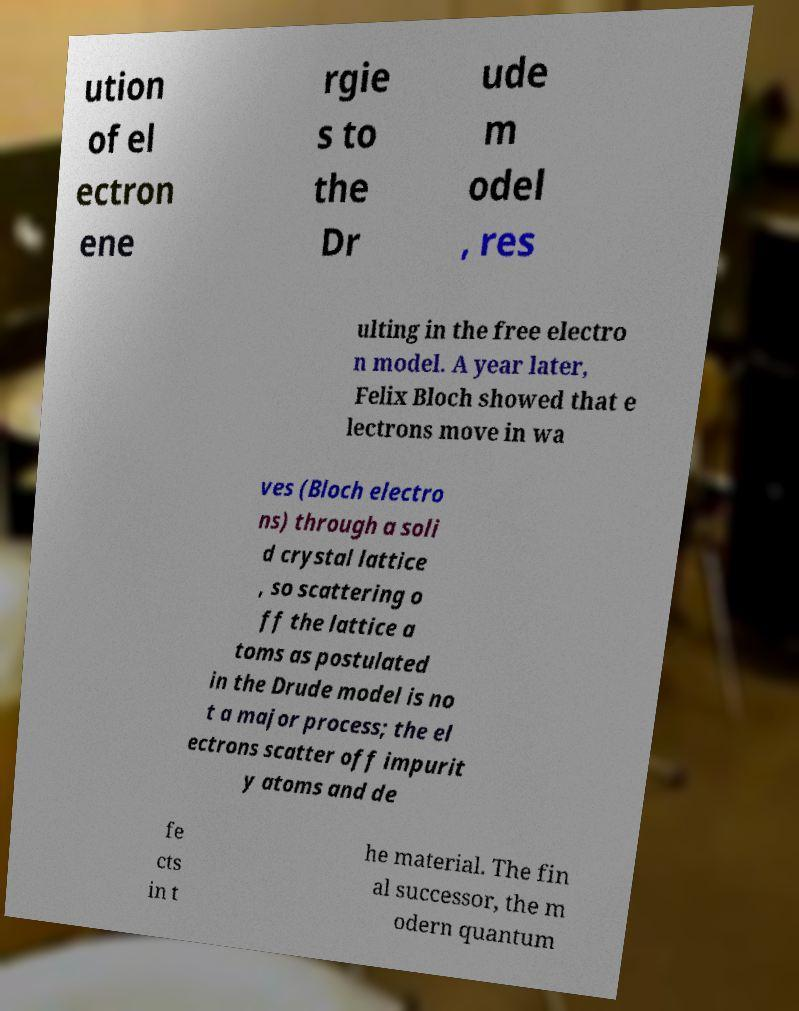There's text embedded in this image that I need extracted. Can you transcribe it verbatim? ution of el ectron ene rgie s to the Dr ude m odel , res ulting in the free electro n model. A year later, Felix Bloch showed that e lectrons move in wa ves (Bloch electro ns) through a soli d crystal lattice , so scattering o ff the lattice a toms as postulated in the Drude model is no t a major process; the el ectrons scatter off impurit y atoms and de fe cts in t he material. The fin al successor, the m odern quantum 